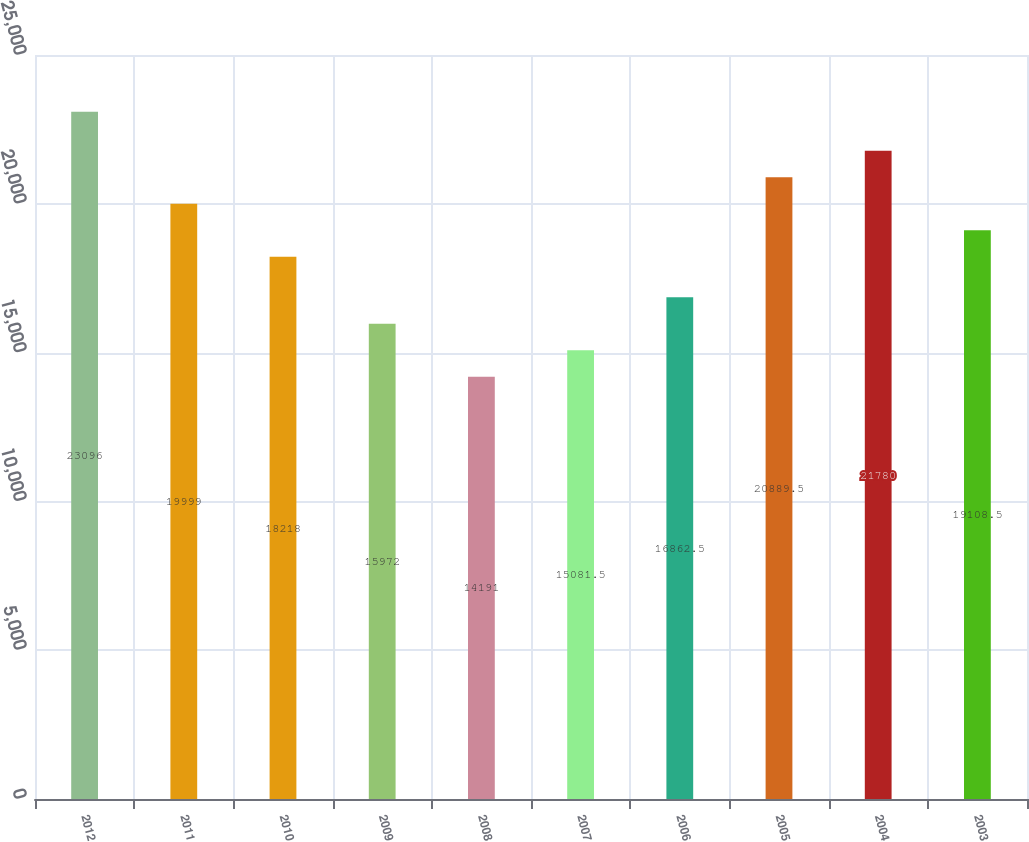Convert chart to OTSL. <chart><loc_0><loc_0><loc_500><loc_500><bar_chart><fcel>2012<fcel>2011<fcel>2010<fcel>2009<fcel>2008<fcel>2007<fcel>2006<fcel>2005<fcel>2004<fcel>2003<nl><fcel>23096<fcel>19999<fcel>18218<fcel>15972<fcel>14191<fcel>15081.5<fcel>16862.5<fcel>20889.5<fcel>21780<fcel>19108.5<nl></chart> 